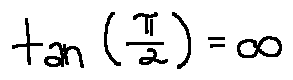Convert formula to latex. <formula><loc_0><loc_0><loc_500><loc_500>\tan ( \frac { \pi } { 2 } ) = \infty</formula> 